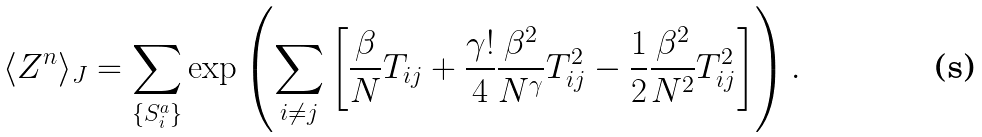Convert formula to latex. <formula><loc_0><loc_0><loc_500><loc_500>\langle Z ^ { n } \rangle _ { J } = \sum _ { \{ S _ { i } ^ { a } \} } \exp \left ( \sum _ { i \neq j } \left [ \frac { \beta } { N } T _ { i j } + \frac { \gamma ! } { 4 } \frac { \beta ^ { 2 } } { N ^ { \gamma } } T _ { i j } ^ { 2 } - \frac { 1 } { 2 } \frac { \beta ^ { 2 } } { N ^ { 2 } } T _ { i j } ^ { 2 } \right ] \right ) .</formula> 